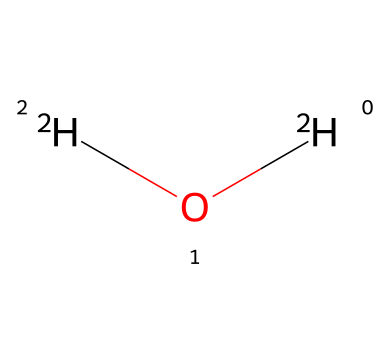what is the chemical name of the substance shown? The SMILES representation [2H]O[2H] indicates that there are two deuterium atoms (2H) bonded to one oxygen atom (O), which is recognized as heavy water.
Answer: heavy water how many deuterium atoms are present in this compound? The SMILES indicates two deuterium atoms ([2H]), showing that there are two of them in the structure.
Answer: 2 what is the ratio of deuterium to oxygen in this chemical? There are two deuterium atoms and one oxygen atom in the structure, giving a ratio of 2:1 for deuterium to oxygen.
Answer: 2:1 what type of chemical bond exists between the atoms shown? The chemical represents deuterium oxide, where covalent bonds are formed between deuterium and oxygen. Such bonds typically involve sharing electrons, which is characteristic of covalent bonding.
Answer: covalent how does the presence of deuterium affect the physical properties compared to regular water? Deuterium, being twice as heavy as hydrogen, increases the mass of water in heavy water. This leads to different physical properties such as higher boiling and melting points compared to regular water due to the presence of deuterium.
Answer: different physical properties is the compound shown radioactive? Heavy water contains stable isotopes of hydrogen (deuterium) and is not radioactive. The compound poses no radioactive risks as all components are stable isotopes.
Answer: no can heavy water be used in nuclear reactors? Heavy water serves as a neutron moderator in certain types of nuclear reactors, which helps to slow down neutrons, allowing for sustained nuclear fission reactions.
Answer: yes 